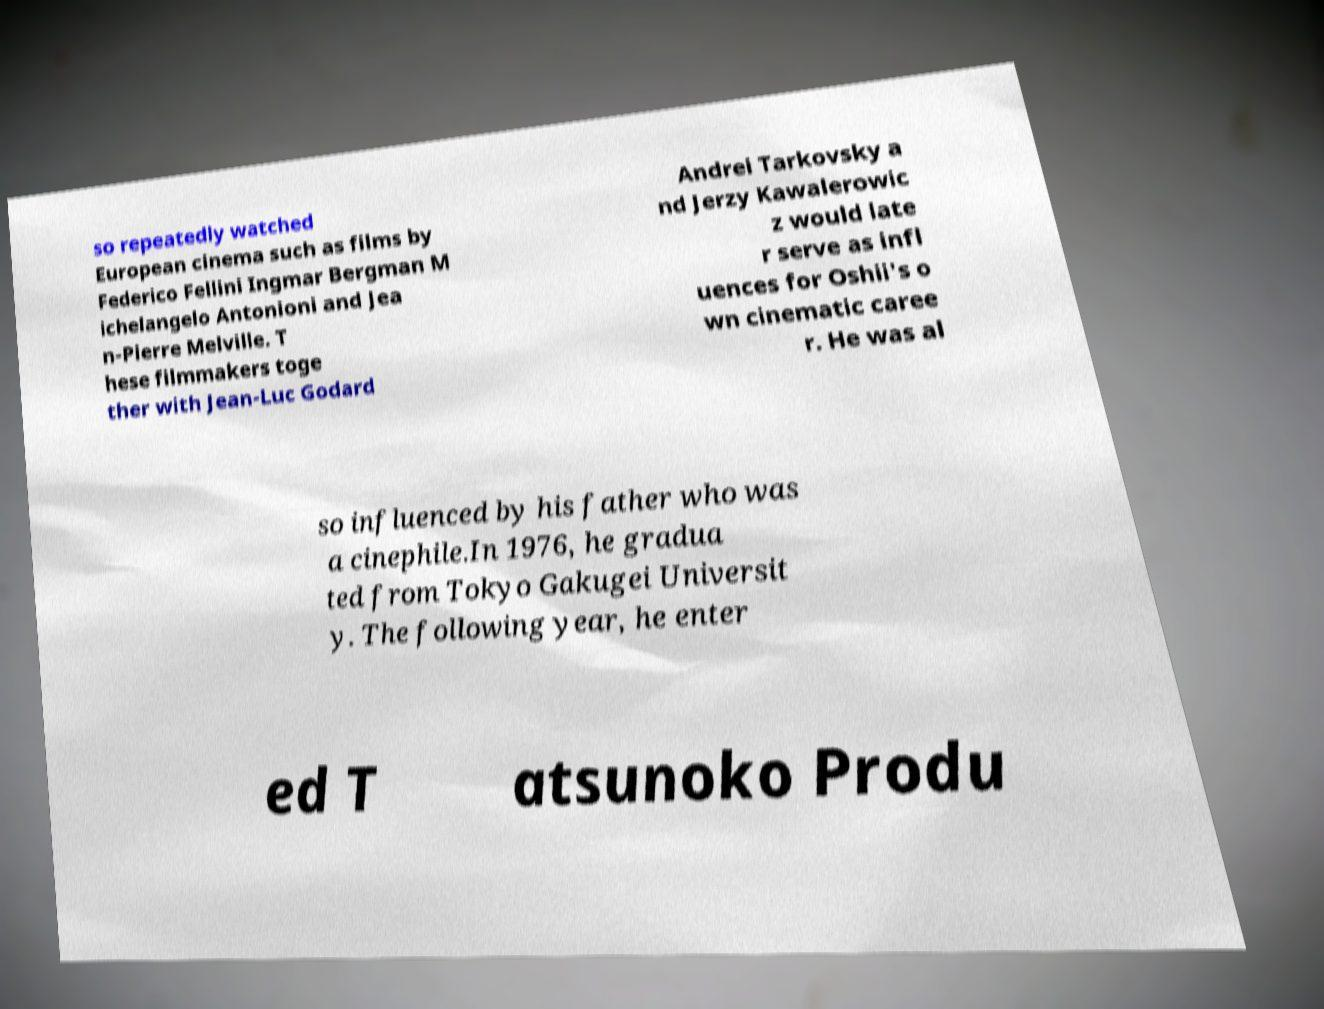Could you assist in decoding the text presented in this image and type it out clearly? so repeatedly watched European cinema such as films by Federico Fellini Ingmar Bergman M ichelangelo Antonioni and Jea n-Pierre Melville. T hese filmmakers toge ther with Jean-Luc Godard Andrei Tarkovsky a nd Jerzy Kawalerowic z would late r serve as infl uences for Oshii's o wn cinematic caree r. He was al so influenced by his father who was a cinephile.In 1976, he gradua ted from Tokyo Gakugei Universit y. The following year, he enter ed T atsunoko Produ 